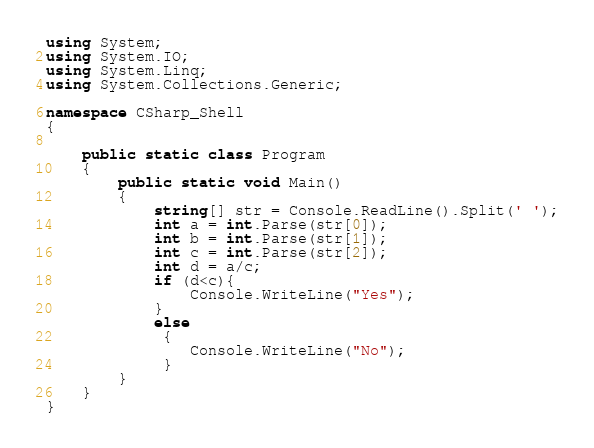Convert code to text. <code><loc_0><loc_0><loc_500><loc_500><_C#_>using System;
using System.IO;
using System.Linq;
using System.Collections.Generic;

namespace CSharp_Shell
{

	public static class Program
	{
		public static void Main()
		{
		    string[] str = Console.ReadLine().Split(' ');
		    int a = int.Parse(str[0]);
			int b = int.Parse(str[1]);
			int c = int.Parse(str[2]);
			int d = a/c;
			if (d<c){
				Console.WriteLine("Yes");
			}
			else
			 {
			 	Console.WriteLine("No");
			 }
		}
	}
}</code> 